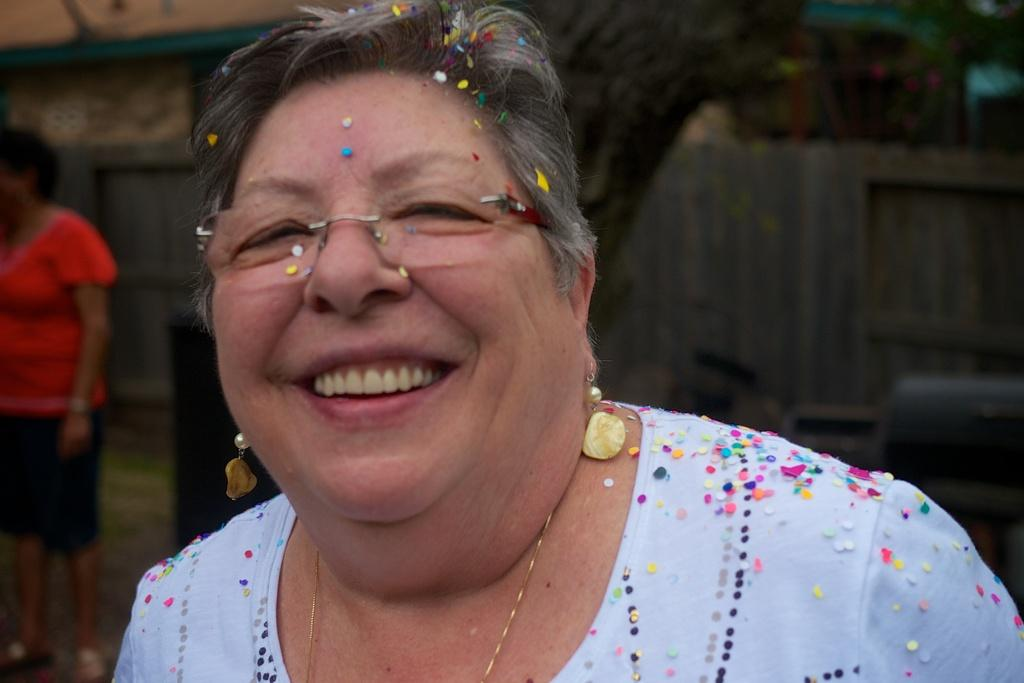What is the woman in the image holding on her? The woman has small papers on her. What can be seen in the background of the image? There is a wooden fence in the image. How many people are present in the image? There is one person standing in the image. What type of coat is the woman wearing in the image? There is no mention of a coat in the image; the woman has small papers on her. --- Transcript: In this picture we can see a man holding a guitar and a microphone. There is a stage and a crowd of people. Facts: 1. There is a man in the image. 2. The man is holding a guitar. 3. The man is holding a microphone. 4. There is a stage in the image. 5. There is a crowd of people in the image. Absurd Topics: painting, ocean, tree Conversation: What is the man in the image holding in his hands? The man is holding a guitar and a microphone. What is the location of the man in the image? The man is on a stage. What can be seen in the background of the image? There is a crowd of people in the image. Reasoning: Let's think step by step in order to produce the conversation. We start by identifying the main subject in the image, which is the man holding a guitar and a microphone. Then, we expand the conversation to include other details about the image, such as the presence of a stage and a crowd of people in the background. Each question is designed to elicit a specific detail about the image that is known from the provided facts. Absurd Question/Answer: Can you see any paintings or trees in the image? No, there are no paintings or trees visible in the image; it features a man on a stage holding a guitar and a microphone, with a crowd of people in the background. --- Transcript: In this image we can see a person sitting on a chair and reading a book. There is a table with a cup of coffee on it. Facts: 1. There is a person in the image. 2. The person is sitting on a chair. 3. The person is reading a book. 4. There is a table in the image. 5. There is a cup of coffee on the table. Absurd Topics: dance, ocean, bird Conversation: What is the person in the image doing while sitting on the chair? The person is reading a book. What can be seen on the table in the image? There is a cup of coffee on the table. Reasoning: Let's think step by step in order to produce the conversation. We start by identifying the main subject in the image, which is the person sitting on a chair and reading a book. Then, we expand the conversation to include other details 